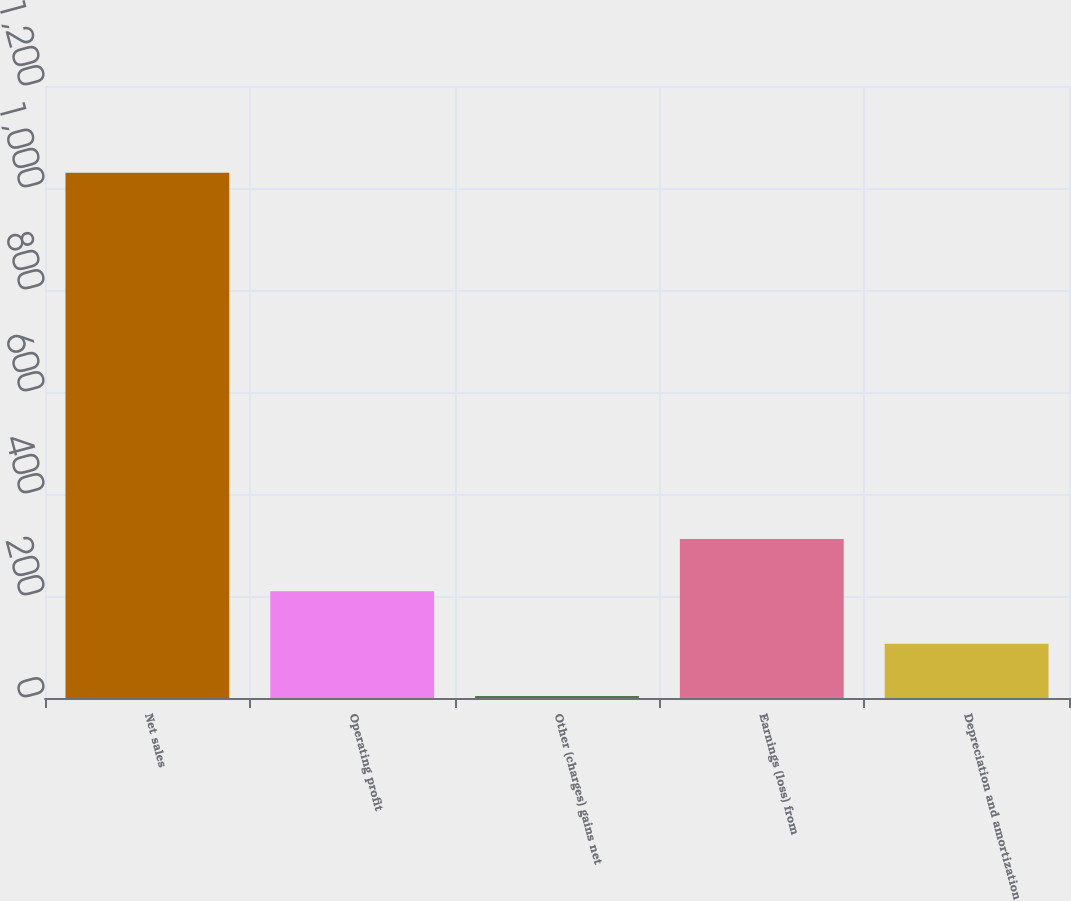<chart> <loc_0><loc_0><loc_500><loc_500><bar_chart><fcel>Net sales<fcel>Operating profit<fcel>Other (charges) gains net<fcel>Earnings (loss) from<fcel>Depreciation and amortization<nl><fcel>1030<fcel>209.2<fcel>4<fcel>311.8<fcel>106.6<nl></chart> 